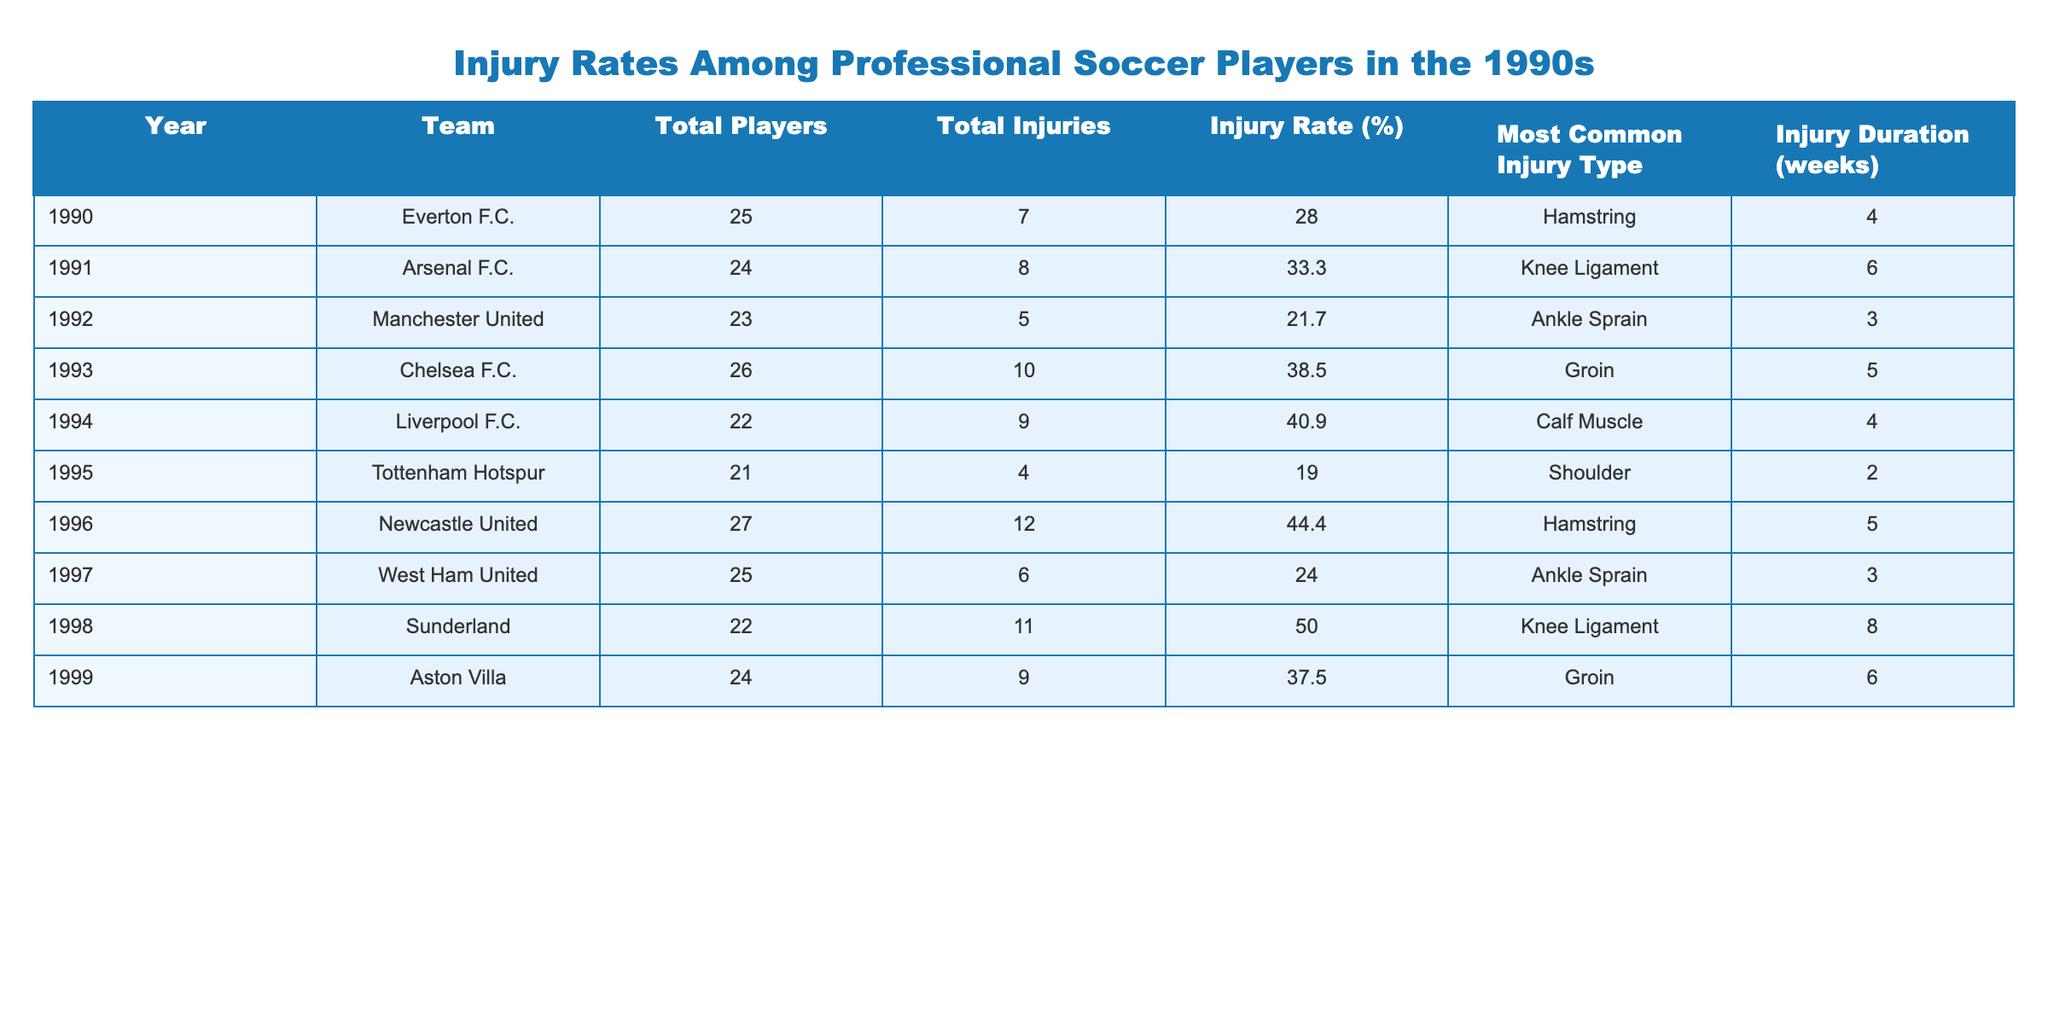What was the highest injury rate among the teams in the 1990s? By reviewing the 'Injury Rate (%)' column, Sunderland has the highest injury rate at 50.0%.
Answer: 50.0% Which team had the most injuries in a single year? Looking at the 'Total Injuries' column, Newcastle United recorded the highest number of injuries with 12 in 1996.
Answer: Newcastle United What is the average injury rate for the years where Liverpool F.C. played? Liverpool was in the data for 1994, having an injury rate of 40.9%. The average only considers this single entry, so the average remains 40.9%.
Answer: 40.9% Were there more injuries among players in 1993 compared to 1992? In 1992, there were 5 injuries, while in 1993 there were 10 injuries. Since 10 is greater than 5, there were indeed more injuries in 1993 compared to 1992.
Answer: Yes How many players were injured for teams with an injury rate above 30%? From the table, the teams with injury rates above 30% are Arsenal (8), Chelsea (10), Liverpool (9), Newcastle (12), and Sunderland (11). Summing these gives a total of 8 + 10 + 9 + 12 + 11 = 50.
Answer: 50 In which year did Everton F.C. have the lowest injury rate, and what was it? Everton's only entry in the table is from 1990, with an injury rate of 28.0%. Since they have only one entry, this is the lowest.
Answer: 28.0% Which common injury type occurred in both 1990 and 1996? Both years listed hamstring as the most common injury type, confirming that it occurred in both instances.
Answer: Hamstring What is the total injury duration for Chelsea and Tottenham for their respective years? Chelsea's injury duration was 5 weeks in 1993, and Tottenham's injury duration was 2 weeks in 1995. Adding these gives 5 + 2 = 7 weeks total injury duration.
Answer: 7 weeks How many teams had an injury rate below 25%? Referring to the 'Injury Rate (%)' column, only Tottenham Hotspur (19.0%) and Manchester United (21.7%) fall below 25%. Thus, there are 2 teams.
Answer: 2 